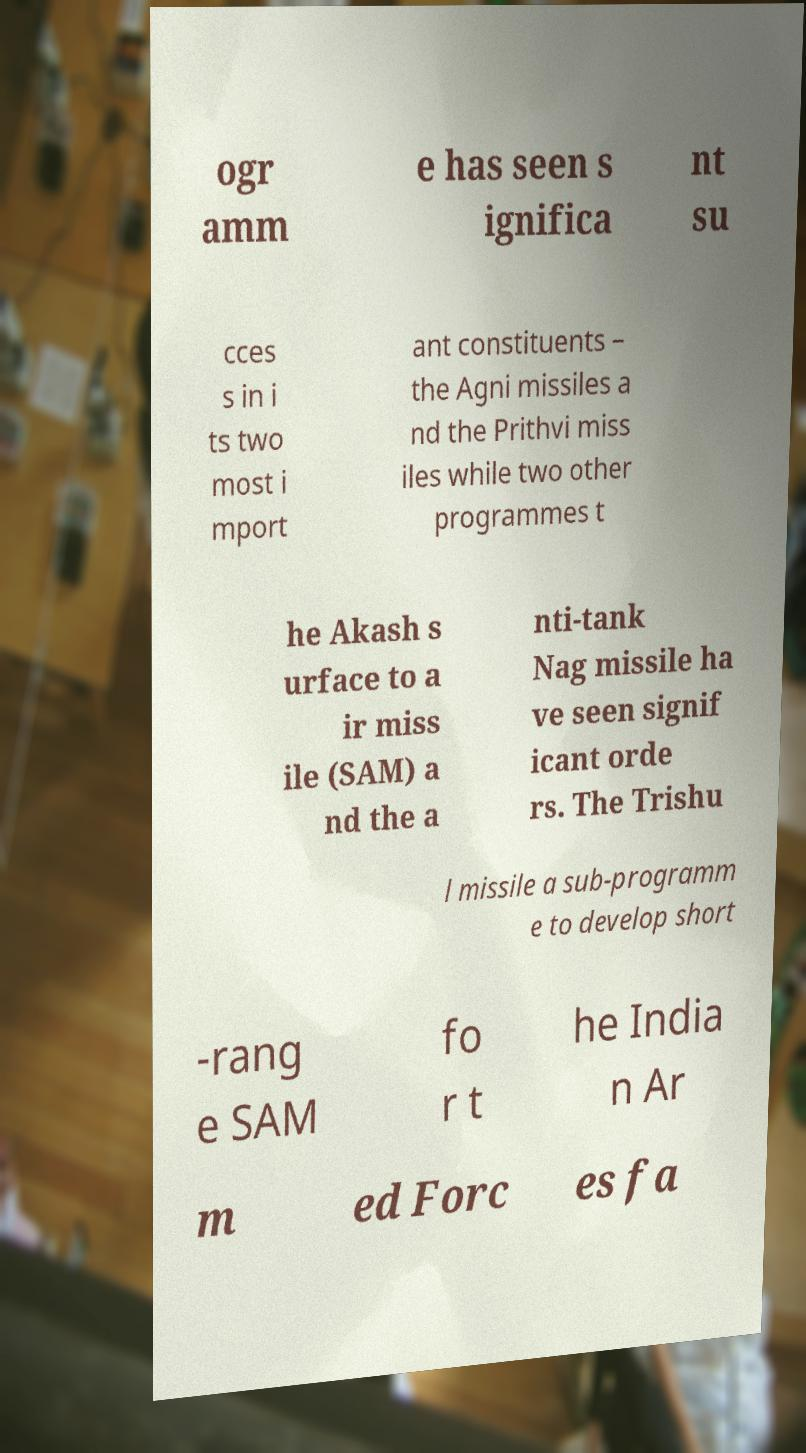What messages or text are displayed in this image? I need them in a readable, typed format. ogr amm e has seen s ignifica nt su cces s in i ts two most i mport ant constituents – the Agni missiles a nd the Prithvi miss iles while two other programmes t he Akash s urface to a ir miss ile (SAM) a nd the a nti-tank Nag missile ha ve seen signif icant orde rs. The Trishu l missile a sub-programm e to develop short -rang e SAM fo r t he India n Ar m ed Forc es fa 